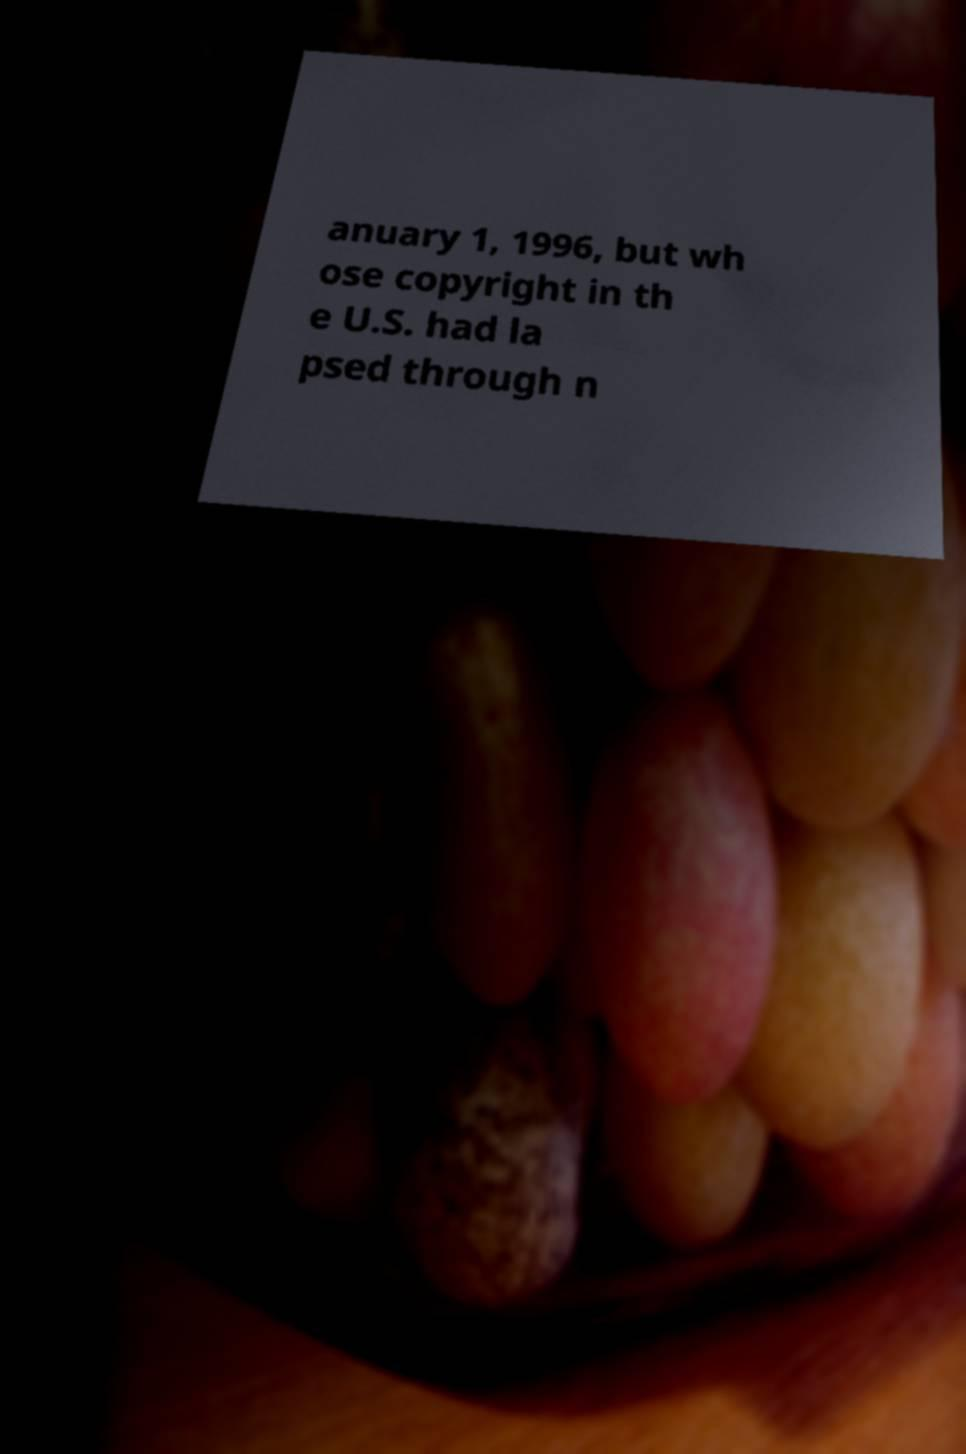Could you assist in decoding the text presented in this image and type it out clearly? anuary 1, 1996, but wh ose copyright in th e U.S. had la psed through n 